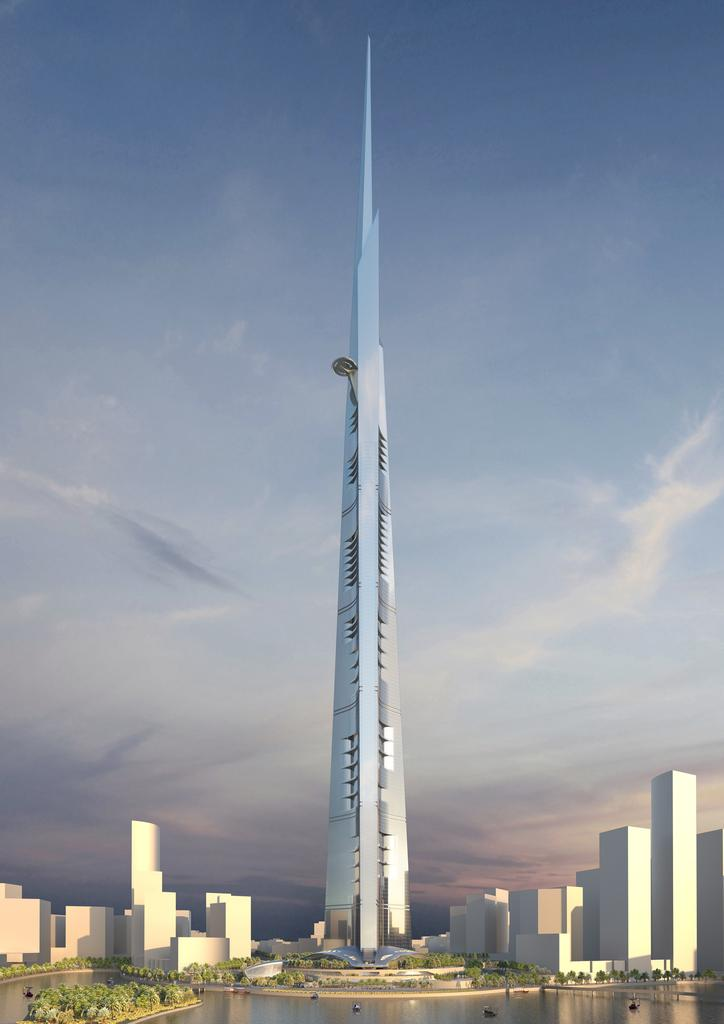What is the main structure in the image? There is a tall tower in the image. What type of vegetation is present around the tower? There are plants around the tower. What natural element can be seen in the image? There is a water surface visible in the image. How many carts are being sorted on the quilt in the image? There are no carts or quilts present in the image. 